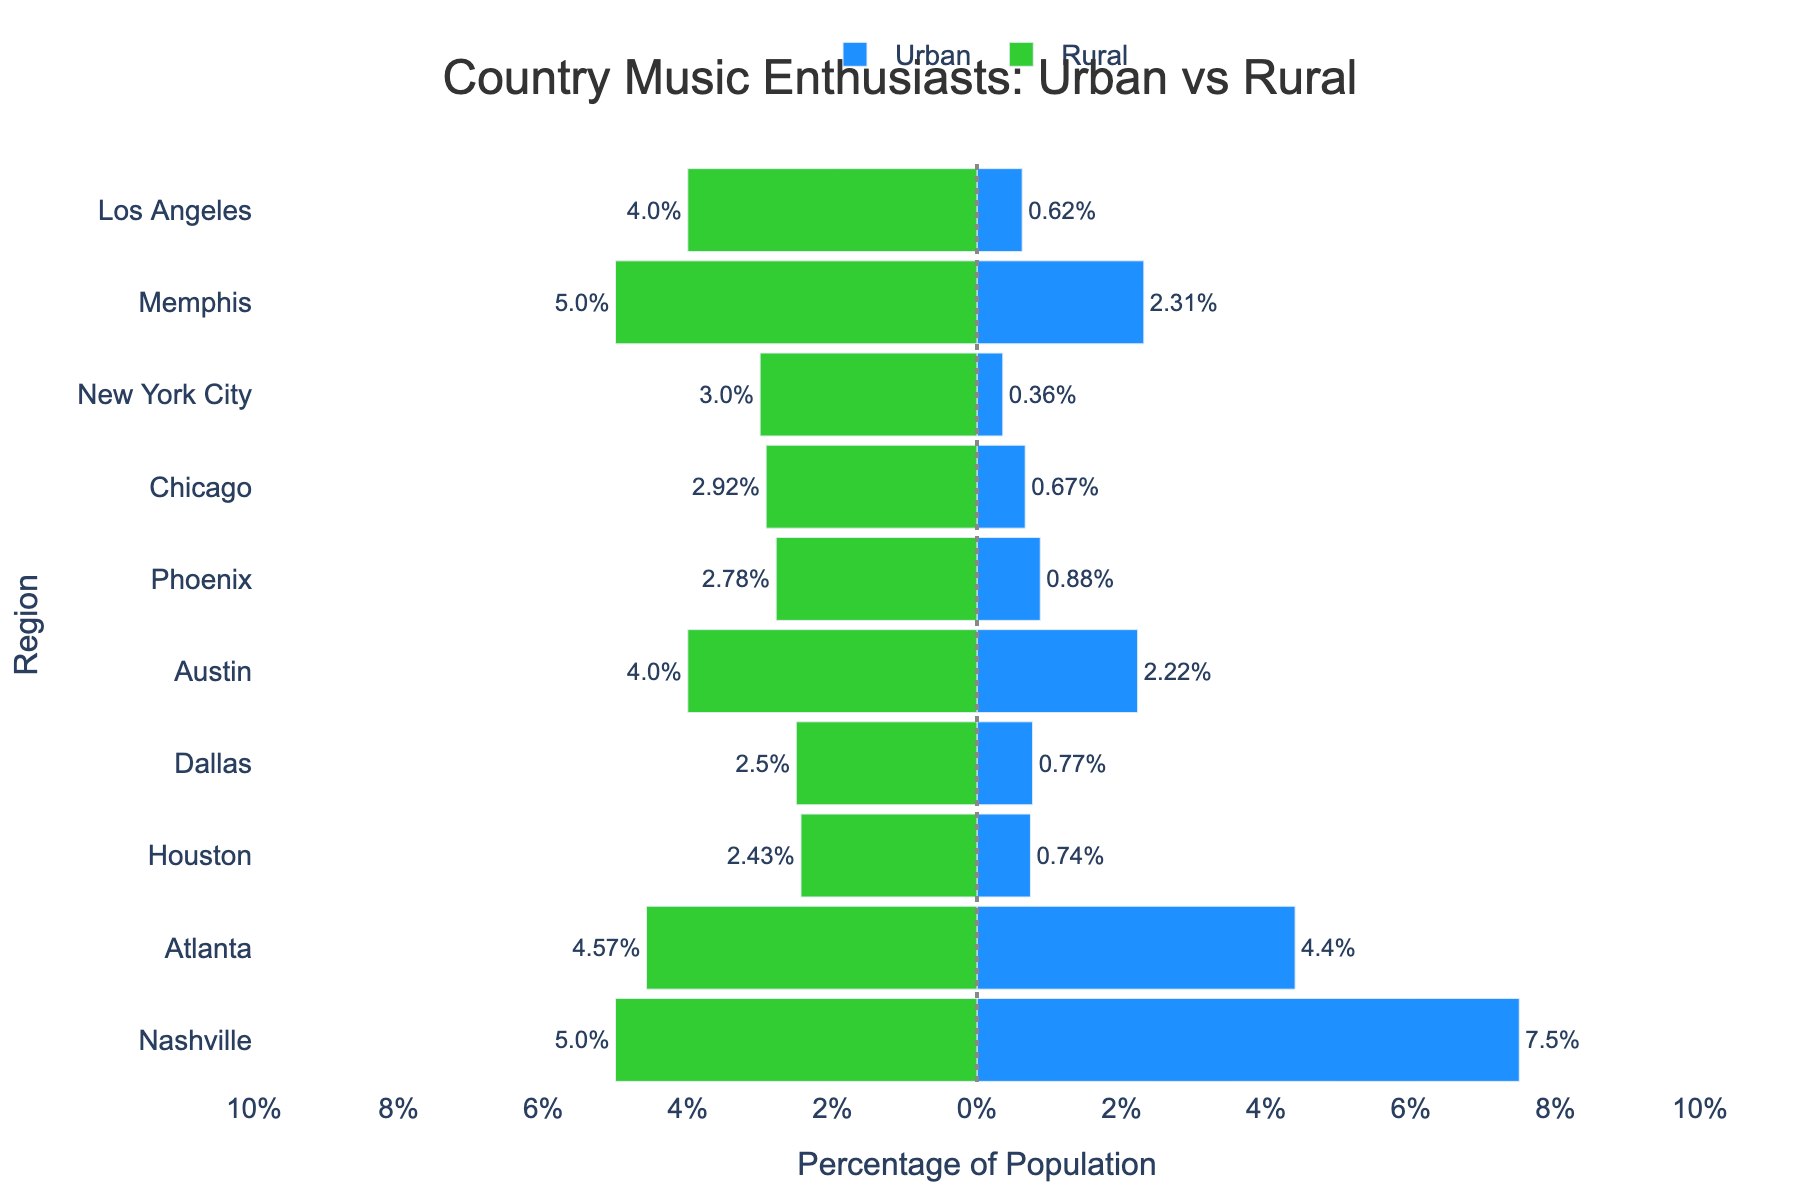Which region shows the highest percentage of country music enthusiasts in urban areas? By looking at the lengths of the blue bars representing urban percentages, Nashville stands out with the longest bar, indicating the highest percentage.
Answer: Nashville Which region has the smallest difference between urban and rural country music enthusiasts' percentages? To find this, look at the regions where the combined total length of the blue and green bars is the smallest. Atlanta shows the smallest difference as its bars are the closest in length.
Answer: Atlanta Identify the region where the rural percentage of country music enthusiasts surpasses the urban percentage. Look for green bars that extend to the right of the zero line further than their corresponding blue bars extend to the right. No region has a green bar longer than its blue bar.
Answer: None Which region has a rural country music enthusiasts' percentage close to 4%? Observing the green bars, Los Angeles has a green bar that extends to the left nearly to the 4% mark, indicating its rural percentage is close to 4%.
Answer: Los Angeles Calculate the average urban percentage of country music enthusiasts across all regions. Adding the percentages directly off the chart: (7.50 + 2.22 + 2.31 + 0.77 + 0.63 + 0.67 + 4.40 + 0.74 + 0.88 + 0.36) = 20.48, then dividing by the number of regions (10), the average is approximately 2.05%.
Answer: 2.05% How much higher is the urban percentage than the rural percentage in Chicago? The urban percentage in Chicago's bar reaches about 0.67%, while the rural percentage reaches about 2.92%. Therefore, the urban percentage is 0.67% higher by calculating (3.59% - 2.92%) = 0.67%.
Answer: 0.67% Which region has the longest green bar indicating the highest rural percentage of enthusiasts? New York City has the longest green bar extending the furthest left, indicating it has the highest rural percentage of about 3%.
Answer: New York City Which regions have an urban percentage higher than 2% but less than 5%? By looking at the blue bars, Memphis (2.31%), Austin (2.22%), and Nashville (7.50%) exceed the 2% mark but do not surpass 5%, except Nashville which is higher than 5%.
Answer: Memphis, Austin 